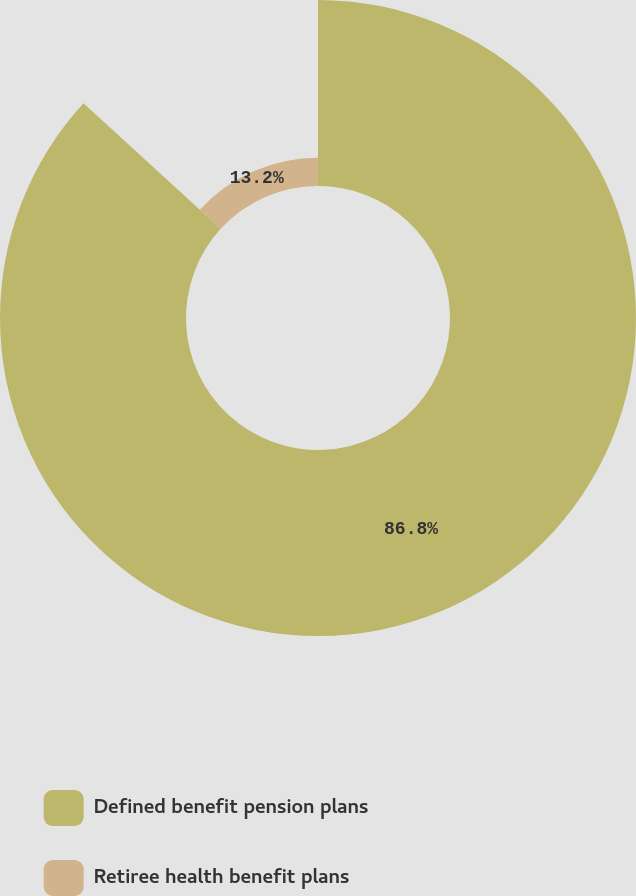<chart> <loc_0><loc_0><loc_500><loc_500><pie_chart><fcel>Defined benefit pension plans<fcel>Retiree health benefit plans<nl><fcel>86.8%<fcel>13.2%<nl></chart> 